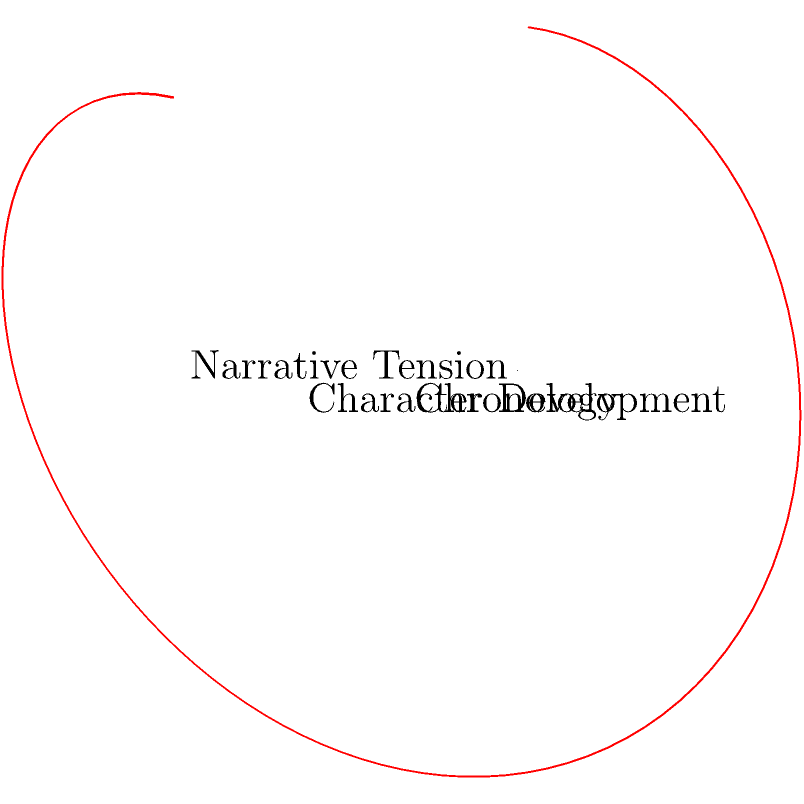In this three-dimensional coordinate system representing the narrative arc of a classic novel, the x-axis represents chronology, the y-axis represents character development, and the z-axis represents narrative tension. What literary technique does the spiral pattern of the plotted line most closely resemble, and how does it contribute to the overall structure of the novel? To answer this question, let's analyze the graph step-by-step:

1. Observe the spiral pattern: The line forms a helix-like shape, rotating around the x-axis as it progresses.

2. Interpret the axes:
   - X-axis (Chronology): The spiral moves consistently along this axis, indicating the linear progression of time in the story.
   - Y-axis (Character Development): The oscillation in this dimension suggests cyclical changes in character growth or regression.
   - Z-axis (Narrative Tension): Similar oscillation here implies rising and falling tension throughout the story.

3. Identify the literary technique: This pattern most closely resembles the technique of "cyclical narrative" or "spiraling plot structure."

4. Analyze the contribution to the novel's structure:
   - Repetition with variation: Each cycle of the spiral represents a recurring theme or situation, but at a different point in the chronology and character development.
   - Layered complexity: As the spiral progresses, it builds upon previous events, adding depth to the narrative.
   - Rhythm and pacing: The regular oscillations in character development and tension create a rhythmic flow to the story.
   - Thematic reinforcement: The cyclical nature allows for repeated exploration and reinforcement of central themes.
   - Character growth: The upward trajectory of the spiral suggests overall character development despite cyclical challenges.

5. Conclude: This spiraling structure contributes to the novel by creating a complex, layered narrative that revisits and builds upon themes and character arcs, while maintaining a sense of forward momentum in the overall story.
Answer: Cyclical narrative/spiraling plot structure; enhances complexity, thematic depth, and character development while maintaining chronological progression. 